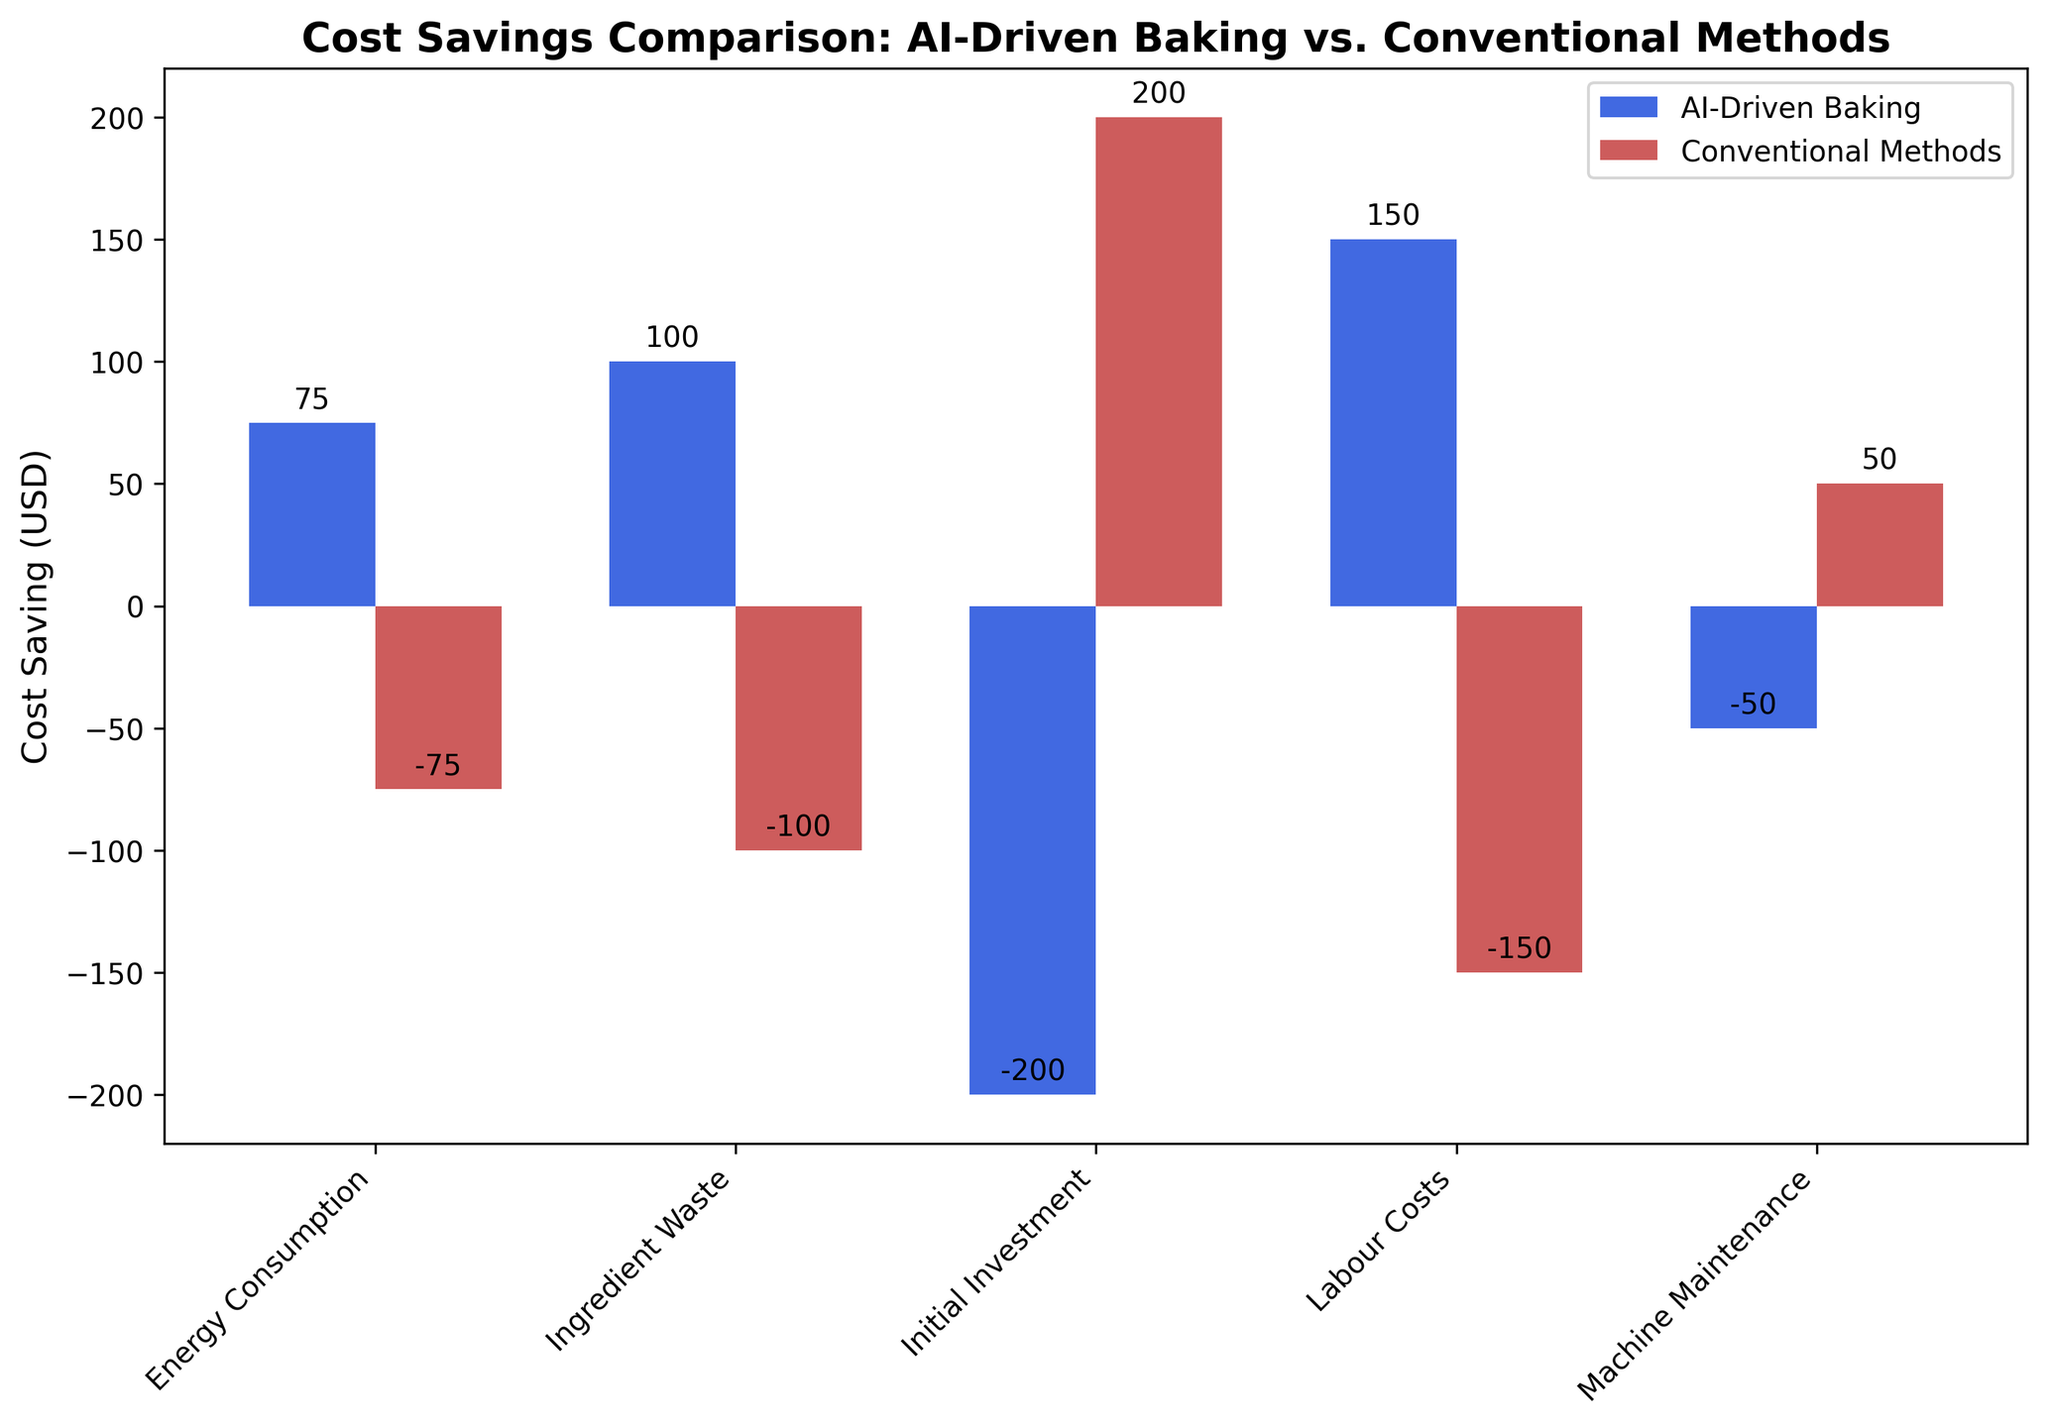Which method has higher labor cost savings? Observe the bars representing labor costs for both methods. The AI-driven method shows a positive value of 150 USD, while the conventional method shows a negative value of -150 USD. Thus, AI-driven baking has higher labor cost savings.
Answer: AI-Driven Baking Which method results in higher overall cost savings in energy consumption? Compare the heights of the bars associated with energy consumption for both methods. The bar for AI-driven baking shows 75 USD, whereas the conventional method shows -75 USD. AI-driven baking results in higher overall cost savings in energy consumption.
Answer: AI-Driven Baking What is the difference in cost savings for machine maintenance between the two methods? Look at the heights of the bars for machine maintenance for both methods: AI-driven baking is at -50 USD, and conventional methods are at 50 USD. The difference is 50 - (-50) = 100 USD.
Answer: 100 USD What is the sum of the initial investment costs for both methods? Observe the bars for initial investment: AI-driven baking is at -200 USD, and conventional methods are at 200 USD. Sum these values: -200 + 200 = 0 USD.
Answer: 0 USD Which cost category has the most significant difference in values between the two methods? Compare the differences in height for each cost category between the two methods. The initial investment category shows the largest difference: 200 - (-200) = 400 USD.
Answer: Initial Investment How do the energy savings of AI-Driven Baking compare with conventional methods? Observe the bars for energy consumption: AI-Driven Baking is 75 USD, while conventional methods show -75 USD. AI-Driven Baking results in positive cost savings, while conventional methods result in a cost increase.
Answer: AI-Driven Baking is higher How much more does AI-Driven baking save on ingredient waste compared to conventional methods? Look at the heights of the bars for ingredient waste: AI-Driven baking shows 100 USD, while conventional methods show -100 USD. The difference is 100 - (-100) = 200 USD.
Answer: 200 USD Which method incurs higher costs in the initial investment? Compare the bars for initial investment: AI-driven baking is at -200 USD, and conventional methods are at 200 USD. AI-driven baking incurs higher costs.
Answer: AI-Driven Baking Calculate the aggregate cost savings across all categories for AI-Driven Baking. Sum the values for AI-Driven Baking: 150 (Labor) + 100 (Ingredient Waste) + 75 (Energy) - 50 (Maintenance) - 200 (Initial Investment) = 75 USD.
Answer: 75 USD 